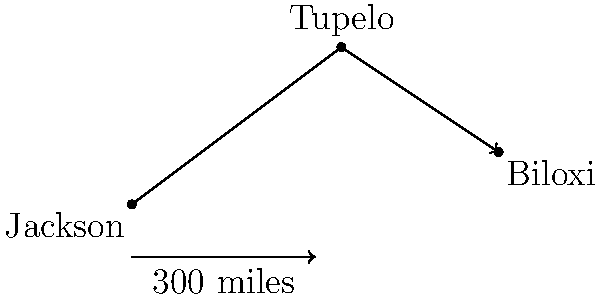As part of your campaign tour across Mississippi, you plan to travel from Jackson to Tupelo, then to Biloxi. The vector from Jackson to Tupelo is $\vec{a} = 4\hat{i} + 3\hat{j}$ (in units of 50 miles), and the vector from Tupelo to Biloxi is $\vec{b} = 3\hat{i} - 2\hat{j}$. What is the magnitude of the resultant vector $\vec{r}$ representing the entire journey from Jackson to Biloxi? To solve this problem, we'll follow these steps:

1) The resultant vector $\vec{r}$ is the sum of vectors $\vec{a}$ and $\vec{b}$:
   $\vec{r} = \vec{a} + \vec{b}$

2) Let's calculate the components of $\vec{r}$:
   $\vec{r} = (4\hat{i} + 3\hat{j}) + (3\hat{i} - 2\hat{j})$
   $\vec{r} = (4+3)\hat{i} + (3-2)\hat{j}$
   $\vec{r} = 7\hat{i} + 1\hat{j}$

3) The magnitude of $\vec{r}$ is given by the Pythagorean theorem:
   $|\vec{r}| = \sqrt{7^2 + 1^2}$

4) Simplify:
   $|\vec{r}| = \sqrt{49 + 1} = \sqrt{50}$

5) Simplify the square root:
   $|\vec{r}| = 5\sqrt{2}$

6) Remember that each unit represents 50 miles, so the actual distance is:
   $5\sqrt{2} \times 50 = 250\sqrt{2}$ miles

Therefore, the magnitude of the resultant vector representing the entire journey from Jackson to Biloxi is $250\sqrt{2}$ miles.
Answer: $250\sqrt{2}$ miles 